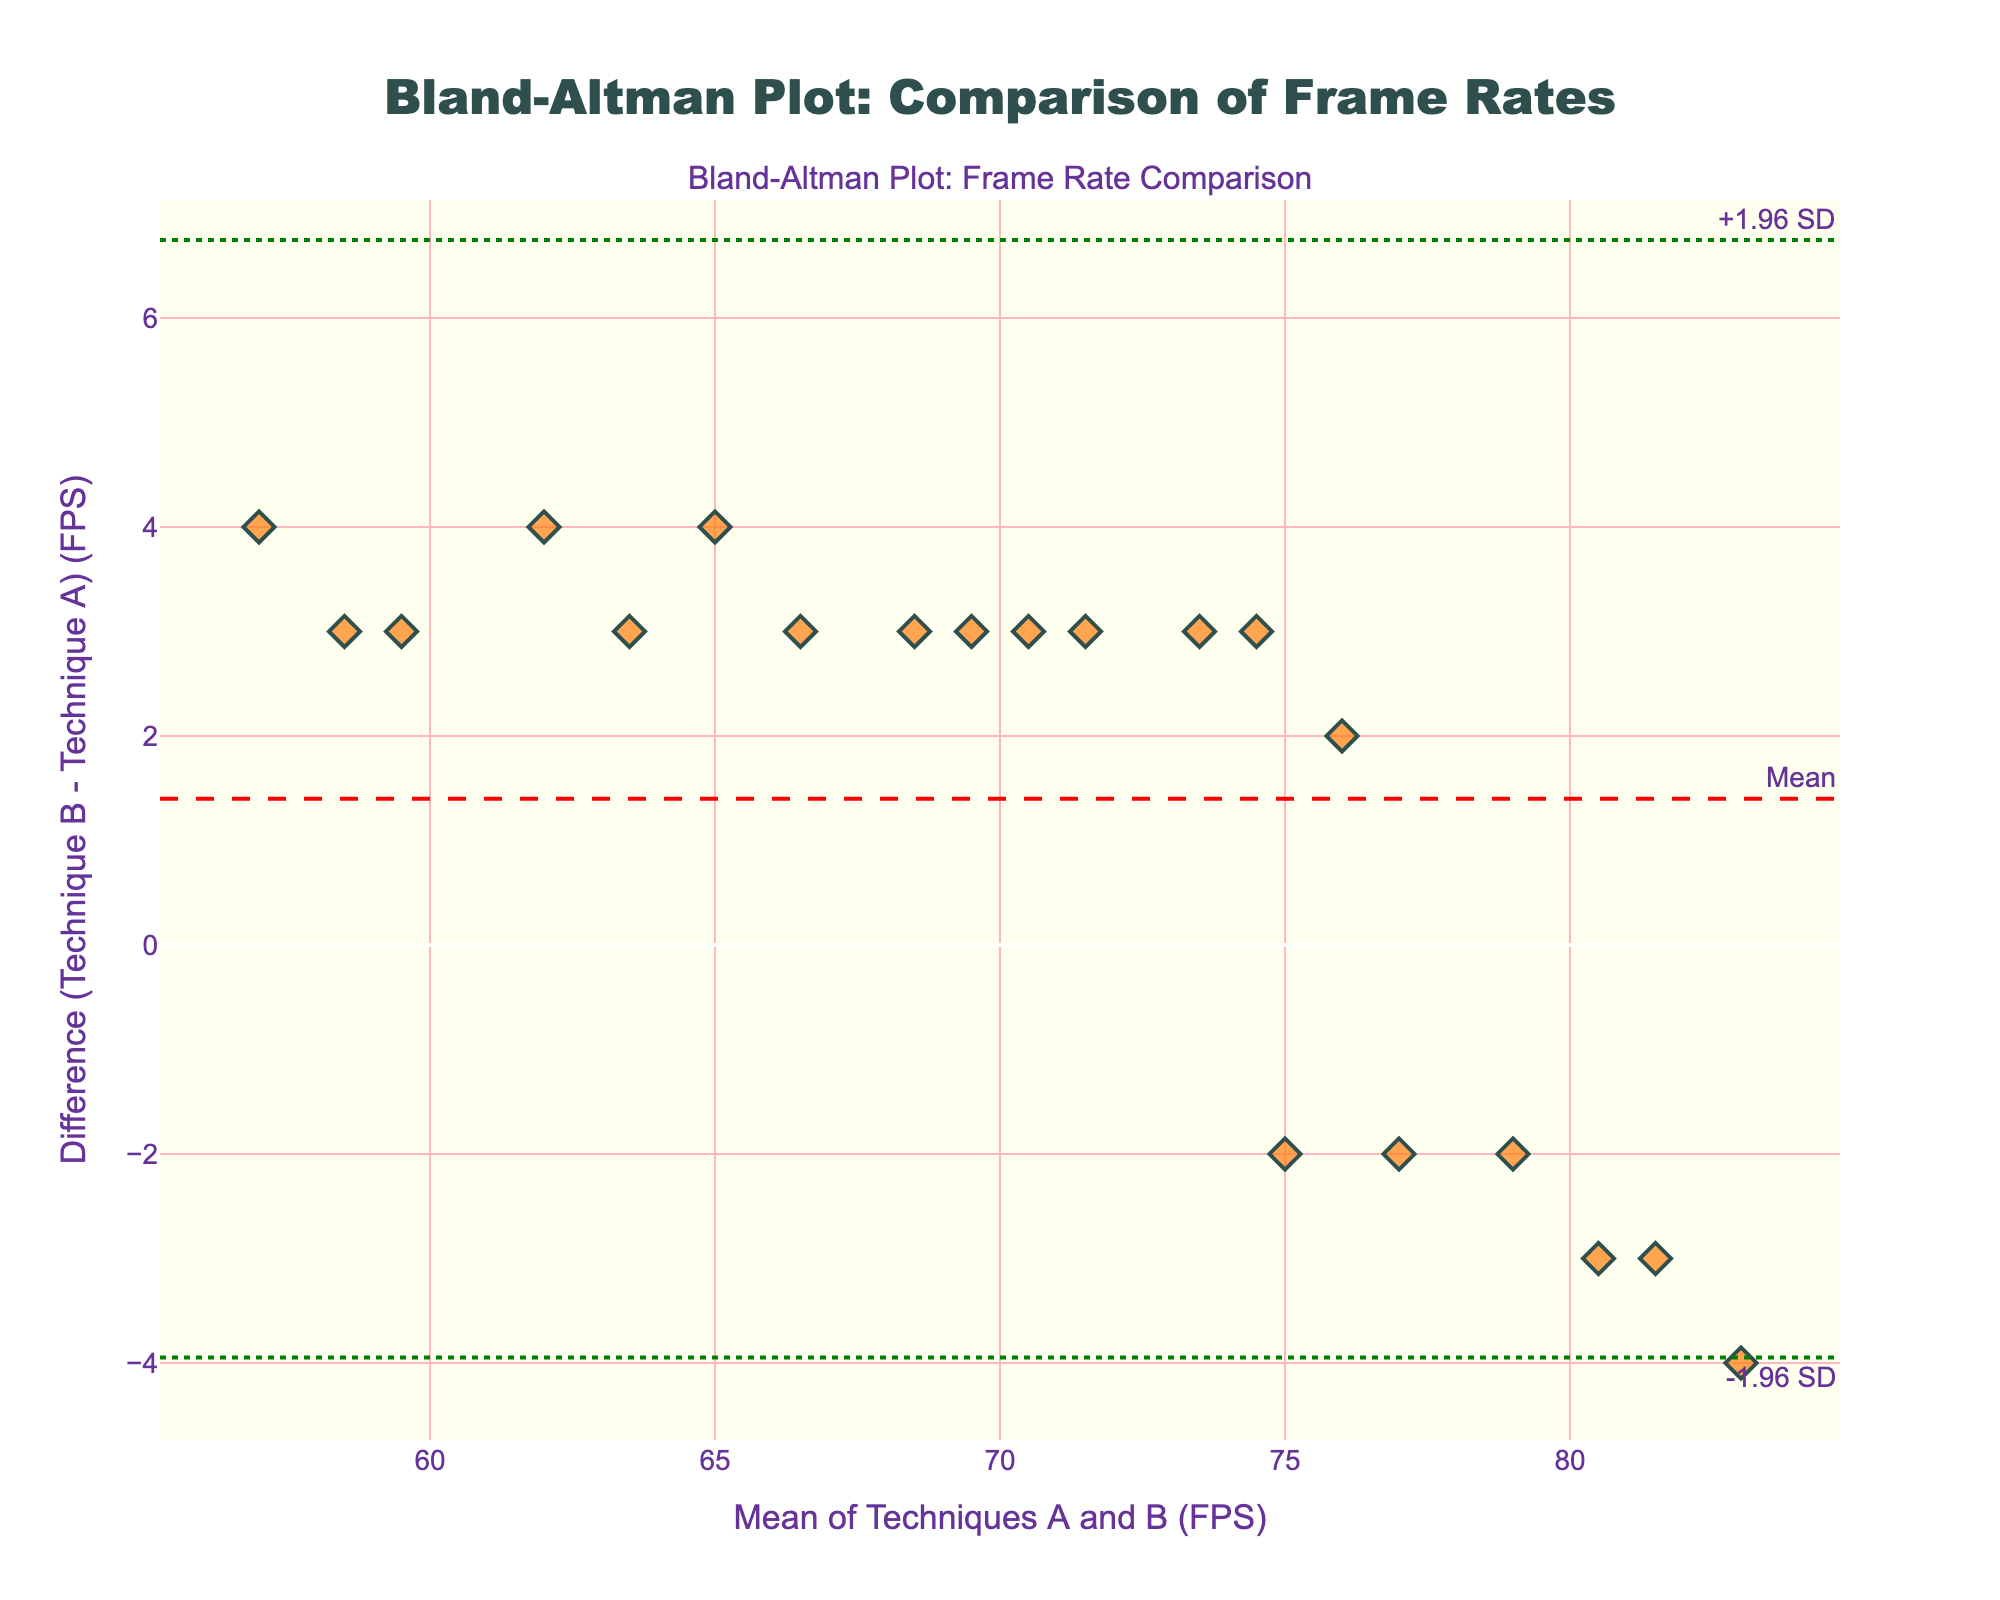What's the title of the figure? The title of the figure is displayed at the top of the plot and typically summarizes the main topic or purpose of the figure. In this case, the title indicates what the plot is representing.
Answer: Bland-Altman Plot: Comparison of Frame Rates What are the x-axis and y-axis labels? The x-axis and y-axis labels describe what each axis represents. The x-axis label is typically found below the x-axis, and the y-axis label is found beside the y-axis.
Answer: Mean of Techniques A and B (FPS); Difference (Technique B - Technique A) (FPS) How many data points are displayed in the plot? The number of data points can be counted by looking at the markers on the plot. Each marker represents a single data point.
Answer: 20 What is the color of the mean difference line? The mean difference line is usually distinguished by a different color and sometimes a different line style. The plot's legend or annotations can provide this information.
Answer: Red What are the limits of agreement in this plot? Limits of agreement are shown as horizontal lines on the plot, often with annotations. They represent ±1.96 standard deviations from the mean difference.
Answer: -1.96 SD: -0.964; +1.96 SD: 4.964 What is the mean difference between the two techniques? The mean difference is represented by a horizontal line drawn across the plot and is often annotated.
Answer: 2.0 Are there any data points outside the limits of agreement? Data points outside the limits of agreement can be identified by observing if any points lie beyond the horizontal lines representing the limits.
Answer: No Is the variability of the differences consistent across the range of mean values? Consistency in variability can be observed by examining the spread of data points vertically across different mean values. If the spread (difference) is roughly the same at all mean values, the variability is consistent.
Answer: Yes What is the maximum difference observed in the plot? The maximum difference can be identified by locating the highest point on the y-axis among the data points.
Answer: 5 Do Technique A and Technique B have similar frame rates? Similarity in frame rates can be inferred if the mean difference is close to zero and the differences between individual points are small and randomly distributed around the mean.
Answer: Generally, yes 